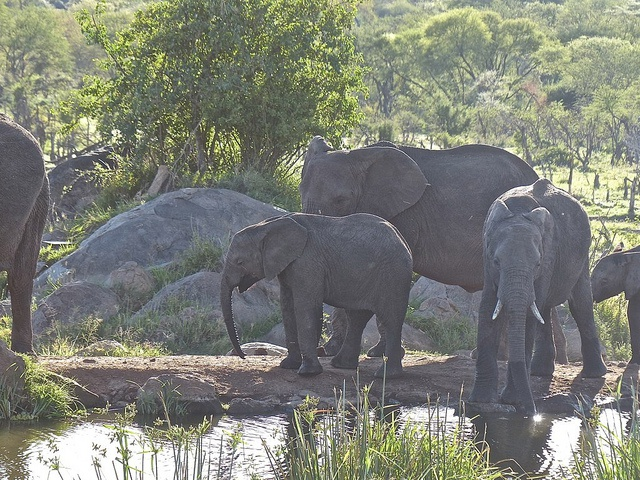Describe the objects in this image and their specific colors. I can see elephant in khaki, gray, darkgray, and black tones, elephant in khaki, gray, darkgray, and lightgray tones, elephant in khaki, gray, darkgray, and lightgray tones, elephant in khaki, gray, darkgray, black, and olive tones, and elephant in khaki, gray, darkgray, and black tones in this image. 